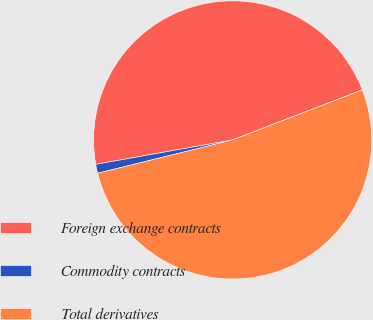Convert chart to OTSL. <chart><loc_0><loc_0><loc_500><loc_500><pie_chart><fcel>Foreign exchange contracts<fcel>Commodity contracts<fcel>Total derivatives<nl><fcel>46.95%<fcel>1.04%<fcel>52.0%<nl></chart> 